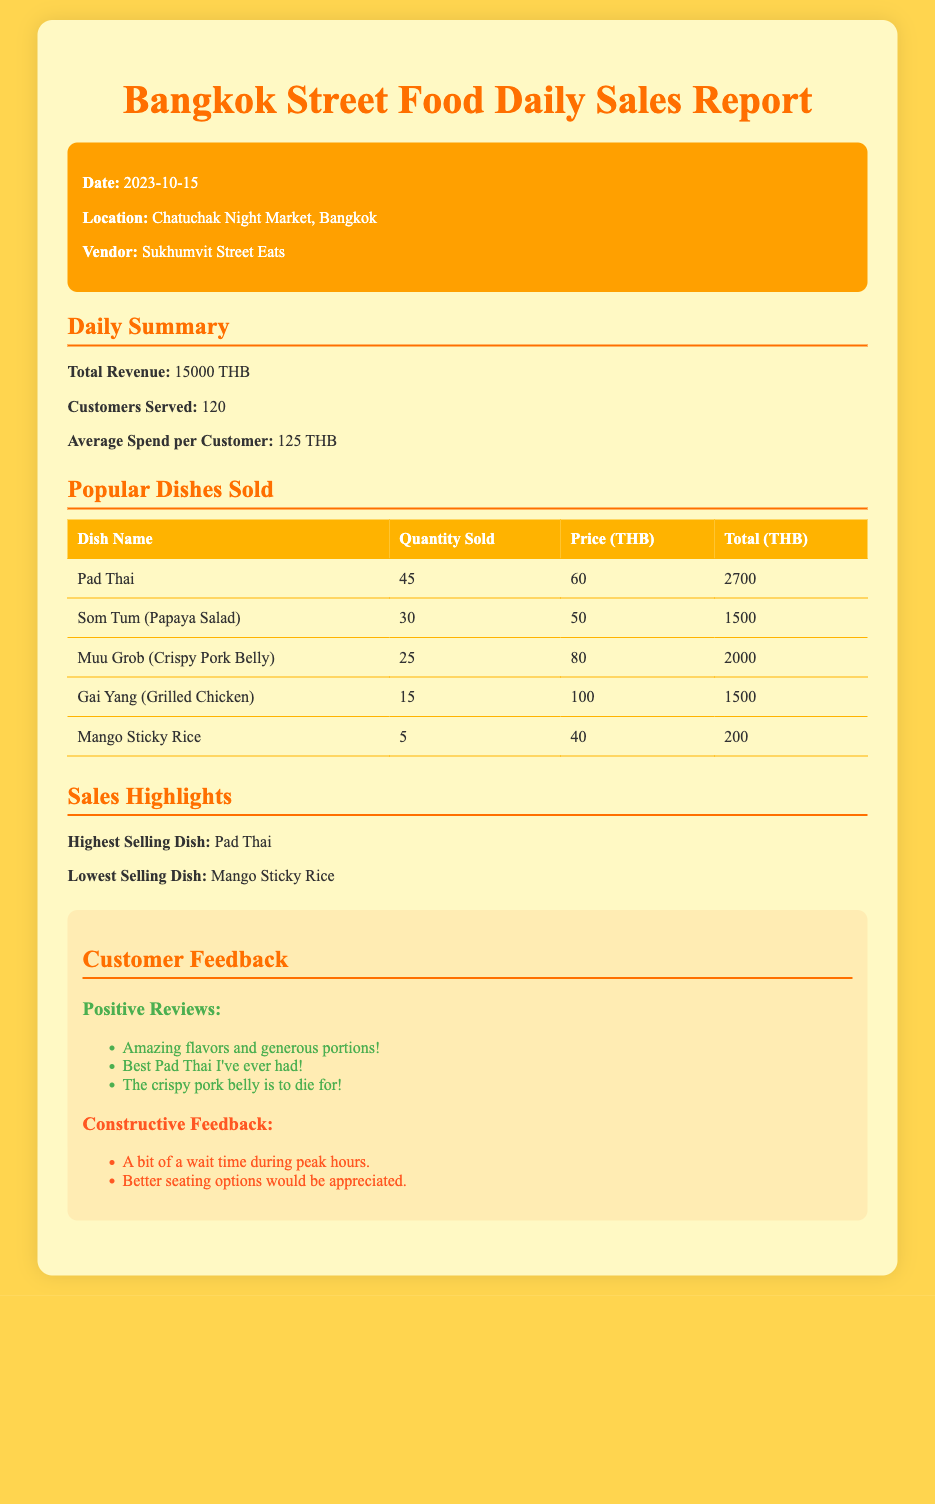What is the total revenue? The total revenue is stated in the daily summary section of the document.
Answer: 15000 THB How many customers were served? The number of customers served is mentioned in the daily summary section of the document.
Answer: 120 What was the average spend per customer? The average spend per customer can be found in the daily summary section.
Answer: 125 THB Which dish was the highest selling? The highest selling dish is indicated in the sales highlights section of the document.
Answer: Pad Thai How many Pad Thai were sold? The quantity of Pad Thai sold is listed in the popular dishes sold table.
Answer: 45 What is the price of Mango Sticky Rice? The price of Mango Sticky Rice is found in the popular dishes sold table.
Answer: 40 THB How many dishes were listed in the popular dishes sold section? The number of dishes listed can be counted from the table in the document.
Answer: 5 What date is the report for? The date is specified in the header section of the document.
Answer: 2023-10-15 What was one of the constructive feedback points? The constructive feedback points are mentioned in the customer feedback section of the document.
Answer: Better seating options would be appreciated 